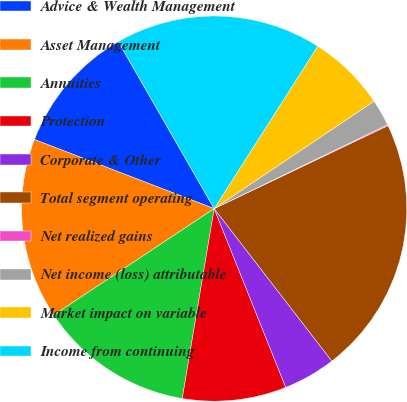<chart> <loc_0><loc_0><loc_500><loc_500><pie_chart><fcel>Advice & Wealth Management<fcel>Asset Management<fcel>Annuities<fcel>Protection<fcel>Corporate & Other<fcel>Total segment operating<fcel>Net realized gains<fcel>Net income (loss) attributable<fcel>Market impact on variable<fcel>Income from continuing<nl><fcel>10.86%<fcel>15.17%<fcel>13.02%<fcel>8.71%<fcel>4.4%<fcel>21.63%<fcel>0.09%<fcel>2.24%<fcel>6.55%<fcel>17.33%<nl></chart> 